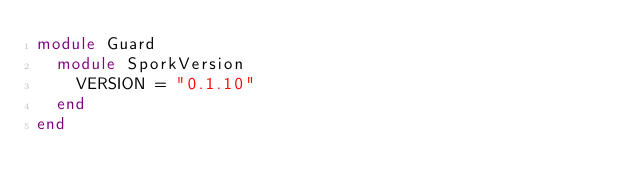Convert code to text. <code><loc_0><loc_0><loc_500><loc_500><_Ruby_>module Guard
  module SporkVersion
    VERSION = "0.1.10"
  end
end
</code> 